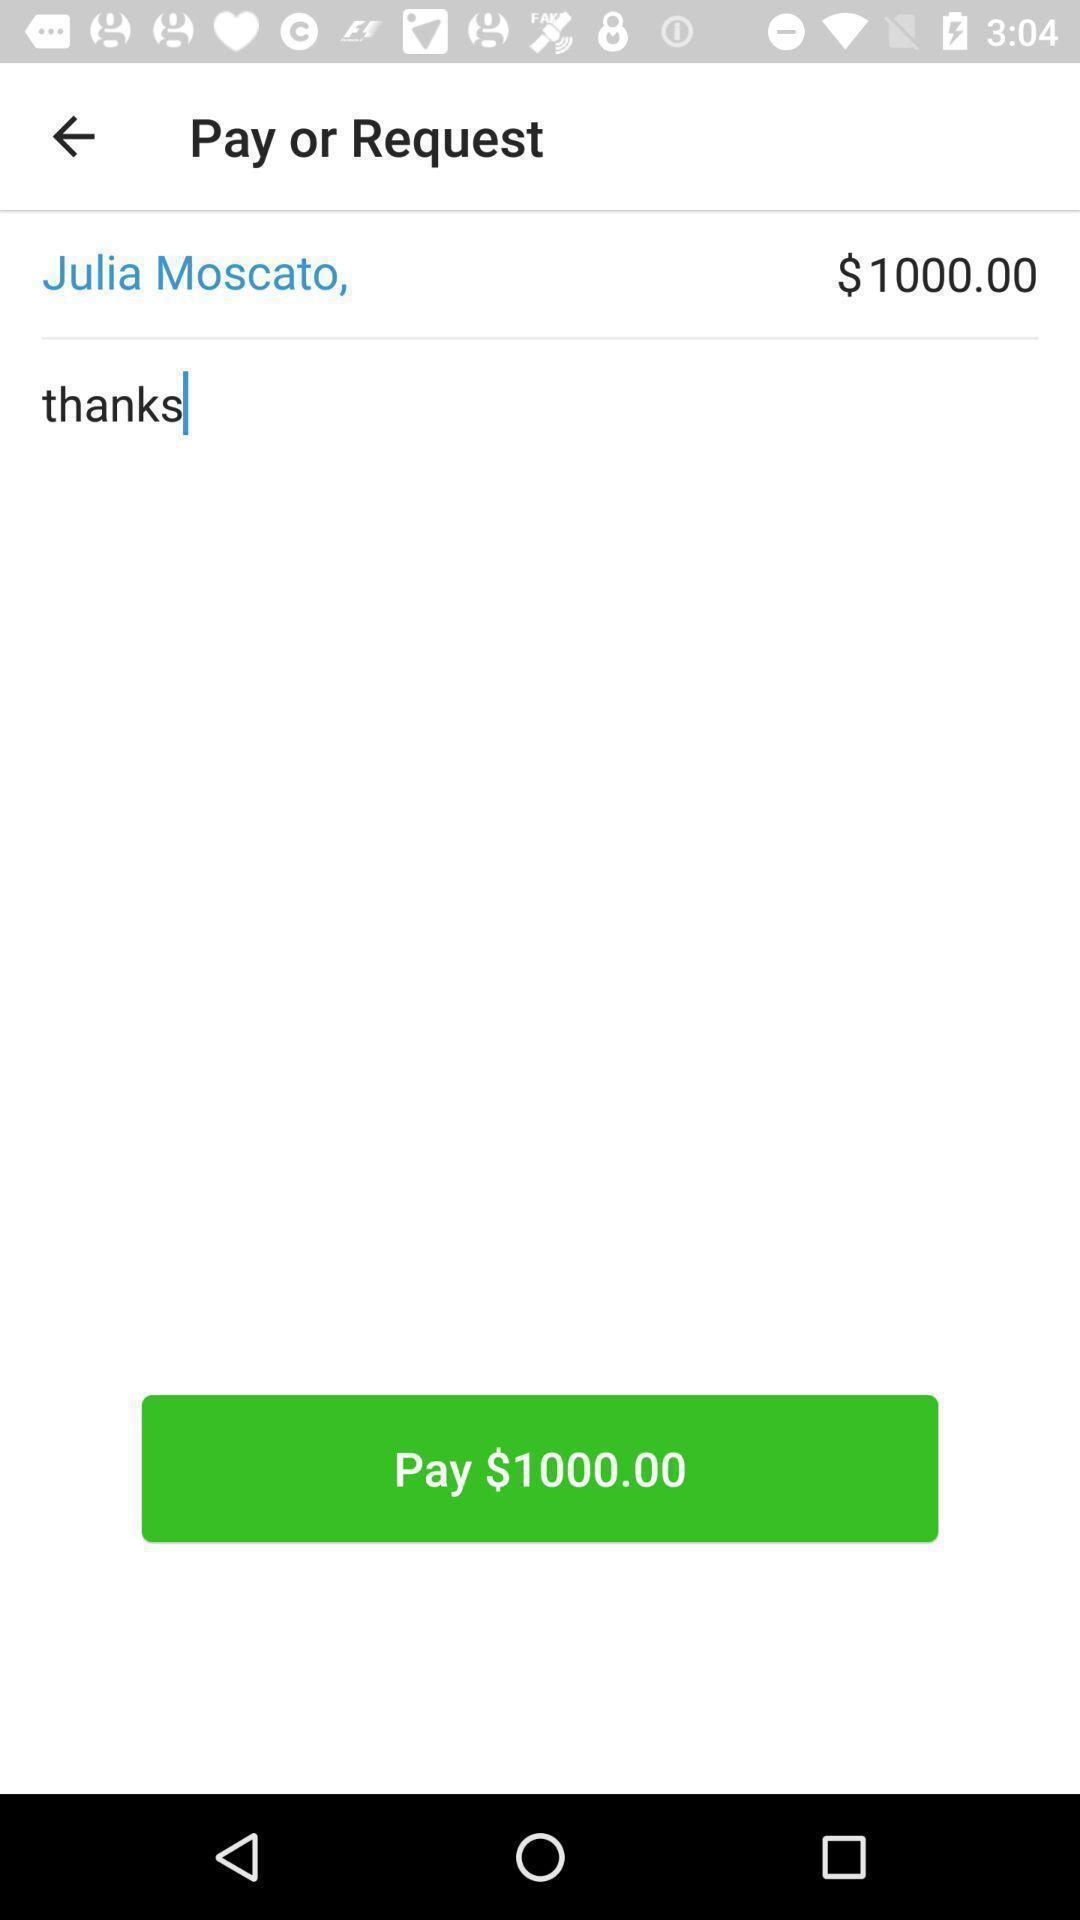Summarize the main components in this picture. Screen showing request page of a payment app. 